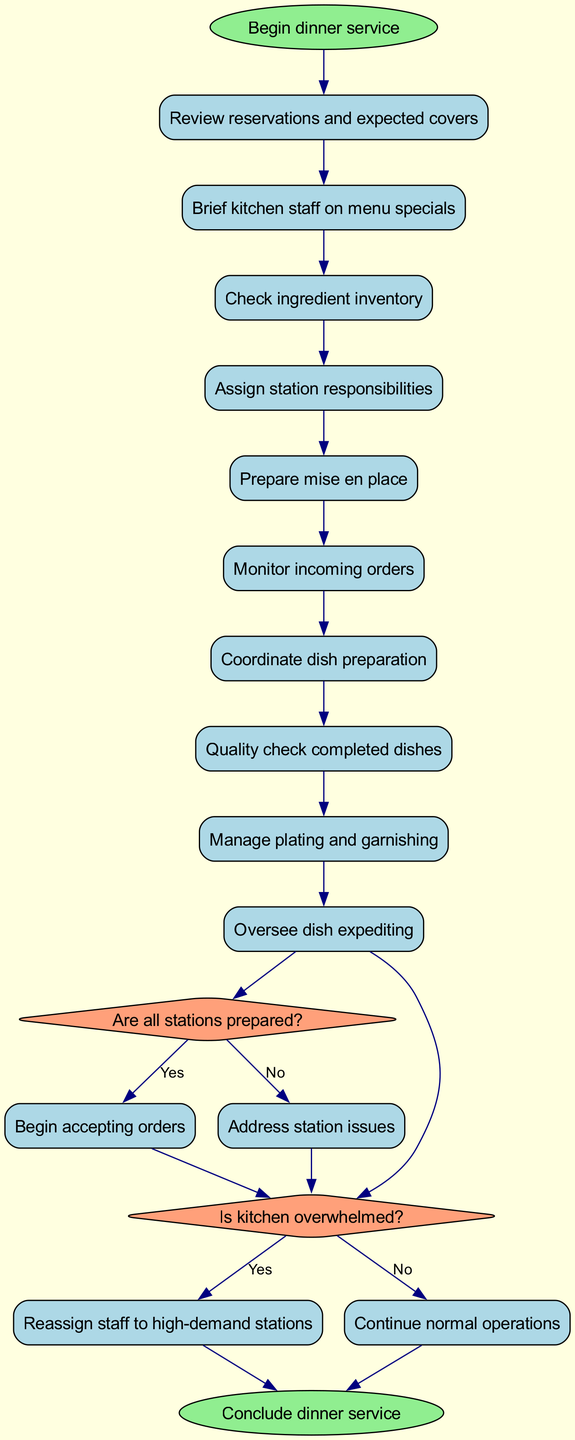What is the first activity in managing dinner service? The first activity listed in the diagram after starting dinner service is "Review reservations and expected covers." This is directly noted as the first activity that follows the start node.
Answer: Review reservations and expected covers How many activities are in the diagram? The diagram includes 10 activities listed sequentially, each one connected to the next until the decision nodes. Counting from the start to the end provides a total of 10 activities.
Answer: 10 What decision follows after "Monitor incoming orders"? Following "Monitor incoming orders," the next activity is a decision node asking, "Are all stations prepared?" This links the activities to the decision-making process in the workflow.
Answer: Are all stations prepared? If the answer to the first decision is "no," what is the next step in the process? If the answer to the decision "Are all stations prepared?" is "no," the next step is to "Address station issues," which is directly linked to the "no" path from that decision.
Answer: Address station issues What happens if the kitchen is overwhelmed? If the kitchen is overwhelmed, the process directs to "Reassign staff to high-demand stations," indicating a response action taken based on the decision made regarding the kitchen's status.
Answer: Reassign staff to high-demand stations How many decisions are present in the diagram? There are 2 decision nodes present in the diagram. These nodes indicate points where specific questions regarding the kitchen's operational status are evaluated.
Answer: 2 What is the final node that concludes the workflow? The final node that concludes the workflow after all decisions and activities is "Conclude dinner service." This indicates the end of the activity flow in the kitchen management process.
Answer: Conclude dinner service Which activity directly precedes the decision about the kitchen being overwhelmed? The activity that directly precedes the decision regarding whether the kitchen is overwhelmed is "Manage plating and garnishing." This reflects the sequence of operations leading into the decision-making point.
Answer: Manage plating and garnishing What does the workflow start with? The workflow starts with the activity labeled "Begin dinner service." This is marked as the beginning point of the entire process outlined in the diagram.
Answer: Begin dinner service 